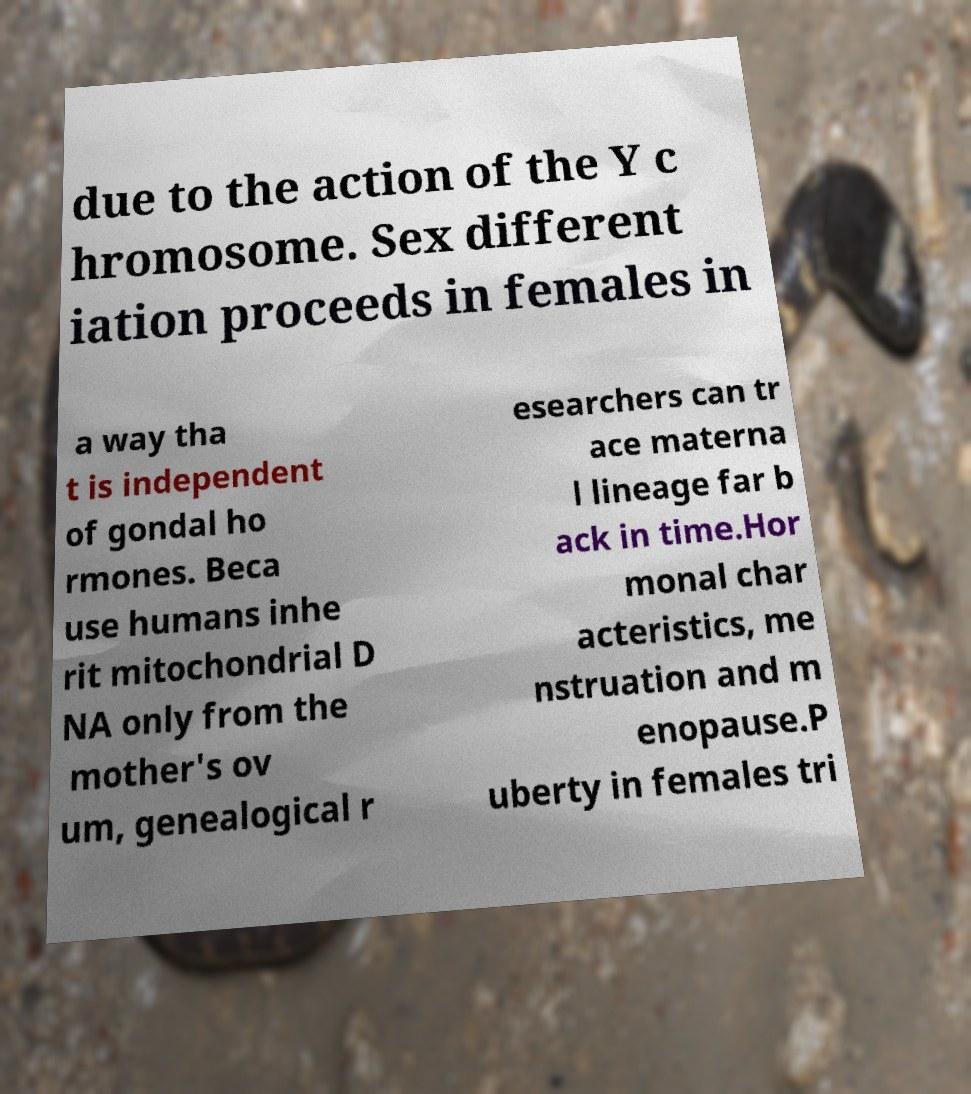For documentation purposes, I need the text within this image transcribed. Could you provide that? due to the action of the Y c hromosome. Sex different iation proceeds in females in a way tha t is independent of gondal ho rmones. Beca use humans inhe rit mitochondrial D NA only from the mother's ov um, genealogical r esearchers can tr ace materna l lineage far b ack in time.Hor monal char acteristics, me nstruation and m enopause.P uberty in females tri 